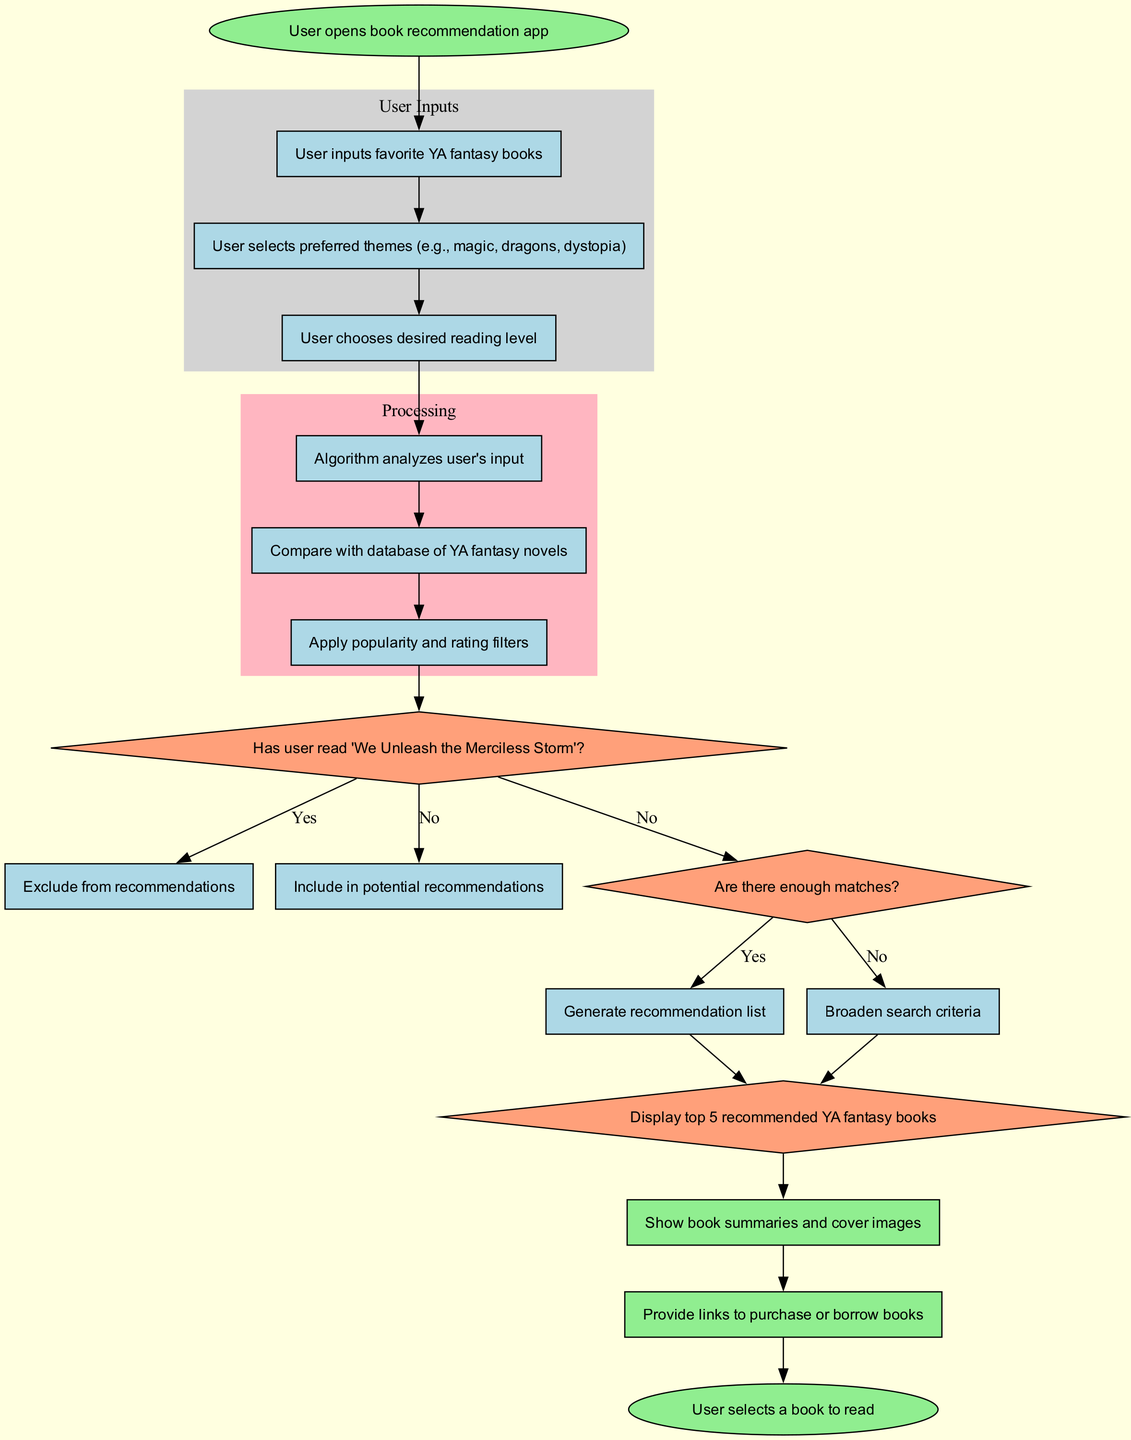What is the first input node in the diagram? The first input node is labeled "User inputs favorite YA fantasy books". It is the first item listed under the 'User Inputs' section and directly follows the 'start' node.
Answer: User inputs favorite YA fantasy books How many outputs are displayed in the diagram? The diagram includes three outputs listed under the 'Outputs' section. Each one represents a different output of the recommendation process.
Answer: 3 What happens if the user has read 'We Unleash the Merciless Storm'? If the user has read "We Unleash the Merciless Storm", the flowchart indicates that the recommendation algorithm will exclude it from recommendations. This corresponds to the 'yes' path stemming from that decision node.
Answer: Exclude from recommendations What is the last step before the user selects a book to read? The last step before the user selects a book to read is displaying the top five recommended YA fantasy books. This occurs before the end node.
Answer: Display top 5 recommended YA fantasy books What decision follows the analysis of user input? The decision that follows the analysis of user input is whether the user has read "We Unleash the Merciless Storm". This is the first decision in the flowchart following the processing steps.
Answer: Has user read 'We Unleash the Merciless Storm'? If the algorithm finds not enough matches, what is the next action? If there are not enough matches, the next action is to broaden the search criteria. This follows the decision node assessing if there are enough matches.
Answer: Broaden search criteria 